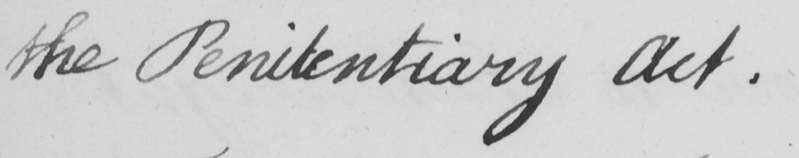Please transcribe the handwritten text in this image. the Penitentiary Act . 